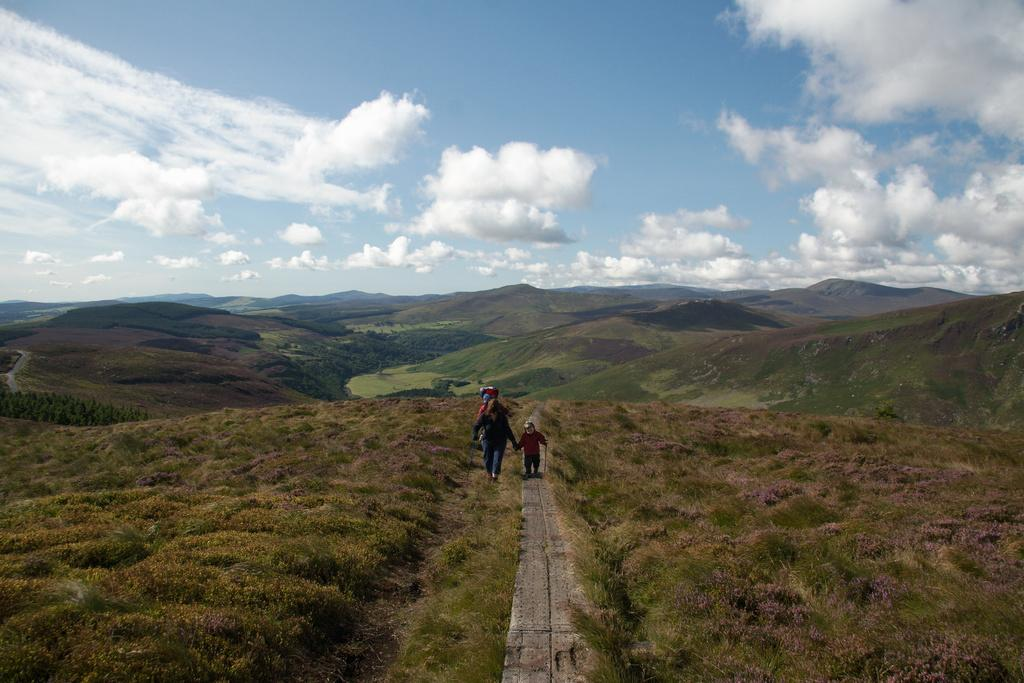What type of living organisms can be seen in the image? Plants are visible in the image. What are the three persons in the image doing? They are walking on the road in the image. What can be seen in the background of the image? Mountains, trees, grass, and the sky are visible in the background of the image. Can you determine the time of day the image was taken? The image was likely taken during the day, as the sky is visible. What type of jelly can be seen on the road in the image? There is no jelly present on the road in the image. What event is taking place in the image? There is no specific event taking place in the image; it simply shows three persons walking on the road and the surrounding landscape. 